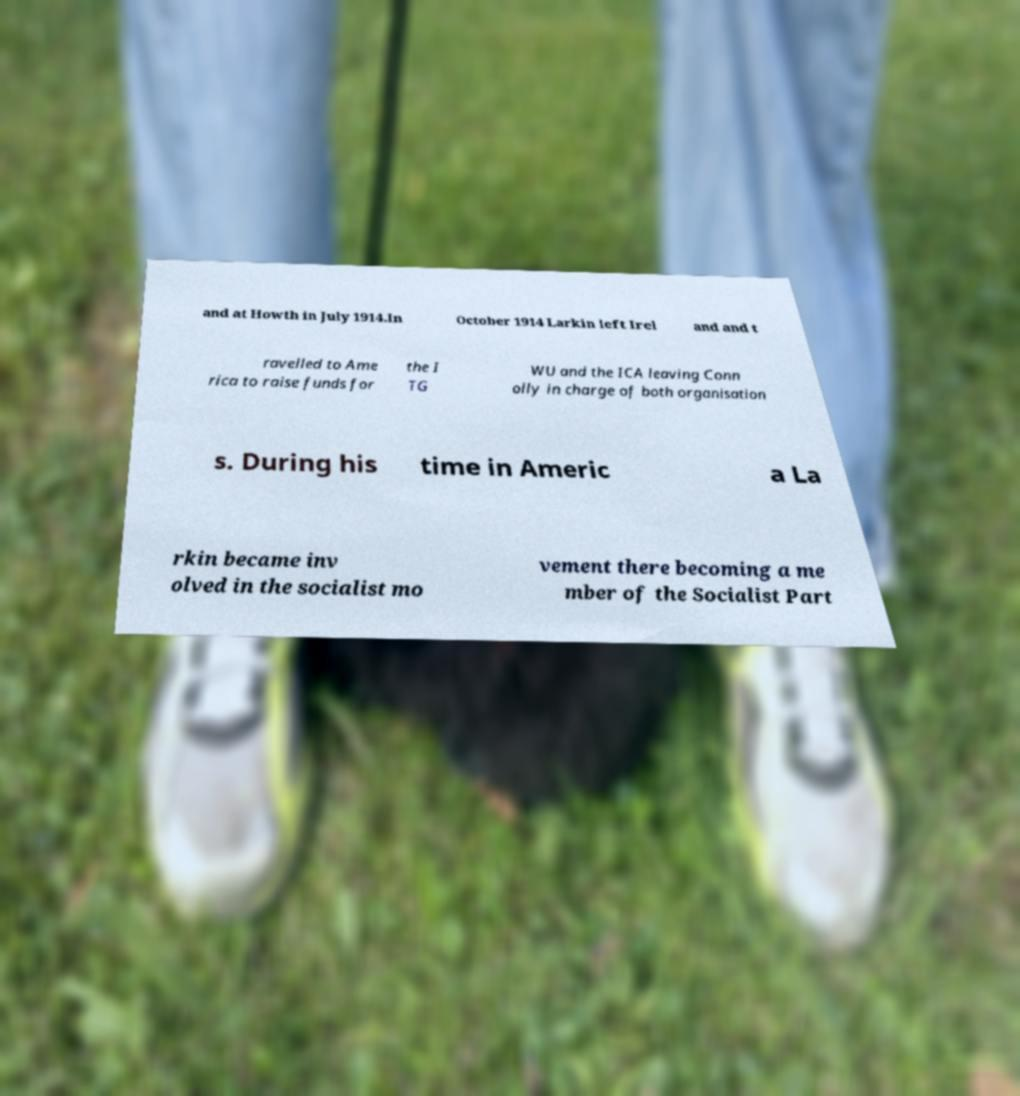For documentation purposes, I need the text within this image transcribed. Could you provide that? and at Howth in July 1914.In October 1914 Larkin left Irel and and t ravelled to Ame rica to raise funds for the I TG WU and the ICA leaving Conn olly in charge of both organisation s. During his time in Americ a La rkin became inv olved in the socialist mo vement there becoming a me mber of the Socialist Part 